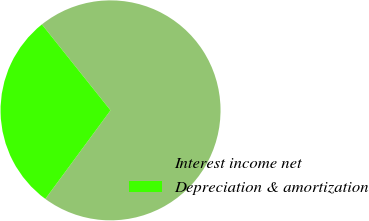Convert chart to OTSL. <chart><loc_0><loc_0><loc_500><loc_500><pie_chart><fcel>Interest income net<fcel>Depreciation & amortization<nl><fcel>70.83%<fcel>29.17%<nl></chart> 